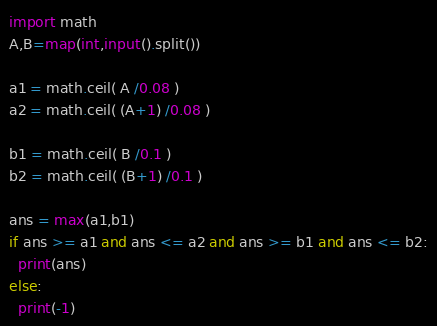<code> <loc_0><loc_0><loc_500><loc_500><_Python_>import math
A,B=map(int,input().split())

a1 = math.ceil( A /0.08 )
a2 = math.ceil( (A+1) /0.08 )

b1 = math.ceil( B /0.1 )
b2 = math.ceil( (B+1) /0.1 )

ans = max(a1,b1)
if ans >= a1 and ans <= a2 and ans >= b1 and ans <= b2:
  print(ans)
else:
  print(-1)</code> 